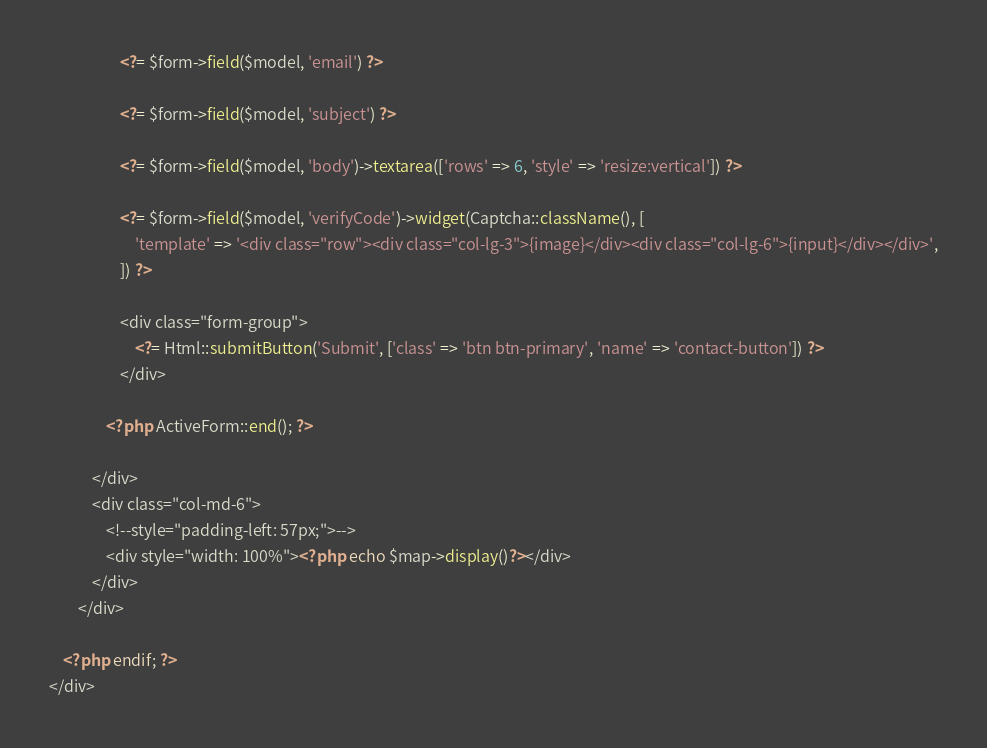<code> <loc_0><loc_0><loc_500><loc_500><_PHP_>                    <?= $form->field($model, 'email') ?>

                    <?= $form->field($model, 'subject') ?>

                    <?= $form->field($model, 'body')->textarea(['rows' => 6, 'style' => 'resize:vertical']) ?>

                    <?= $form->field($model, 'verifyCode')->widget(Captcha::className(), [
                        'template' => '<div class="row"><div class="col-lg-3">{image}</div><div class="col-lg-6">{input}</div></div>',
                    ]) ?>

                    <div class="form-group">
                        <?= Html::submitButton('Submit', ['class' => 'btn btn-primary', 'name' => 'contact-button']) ?>
                    </div>

                <?php ActiveForm::end(); ?>

            </div>
            <div class="col-md-6">
                <!--style="padding-left: 57px;">-->
                <div style="width: 100%"><?php echo $map->display()?></div>
            </div>
        </div>

    <?php endif; ?>
</div>
</code> 